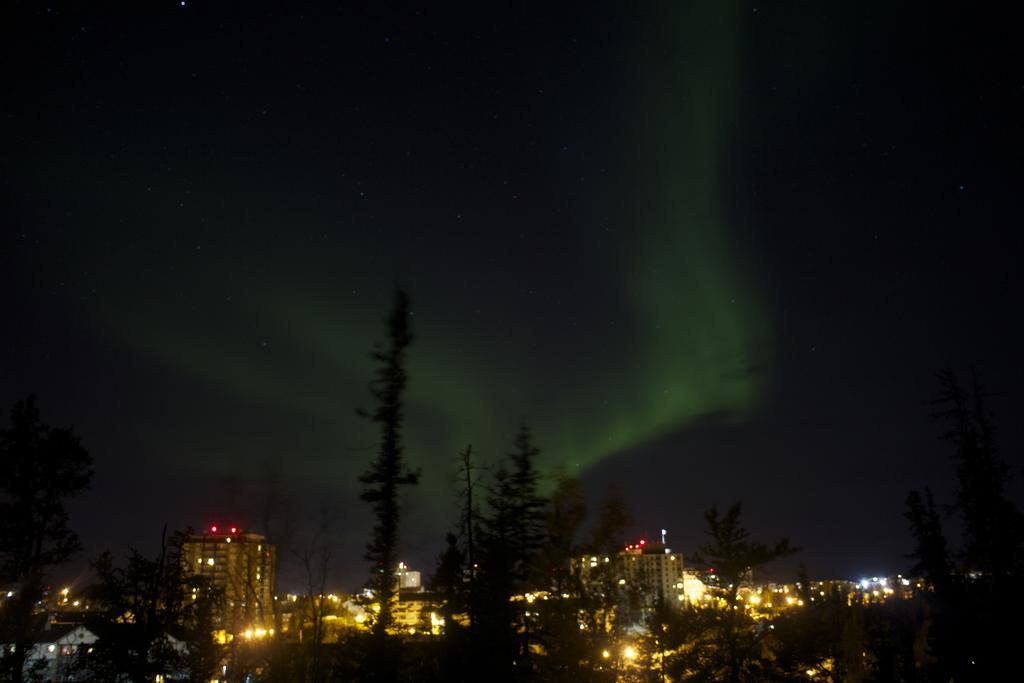How would you summarize this image in a sentence or two? In this image I can see many trees. In the background I can see the buildings with lights. I can also see the sky in the back. 